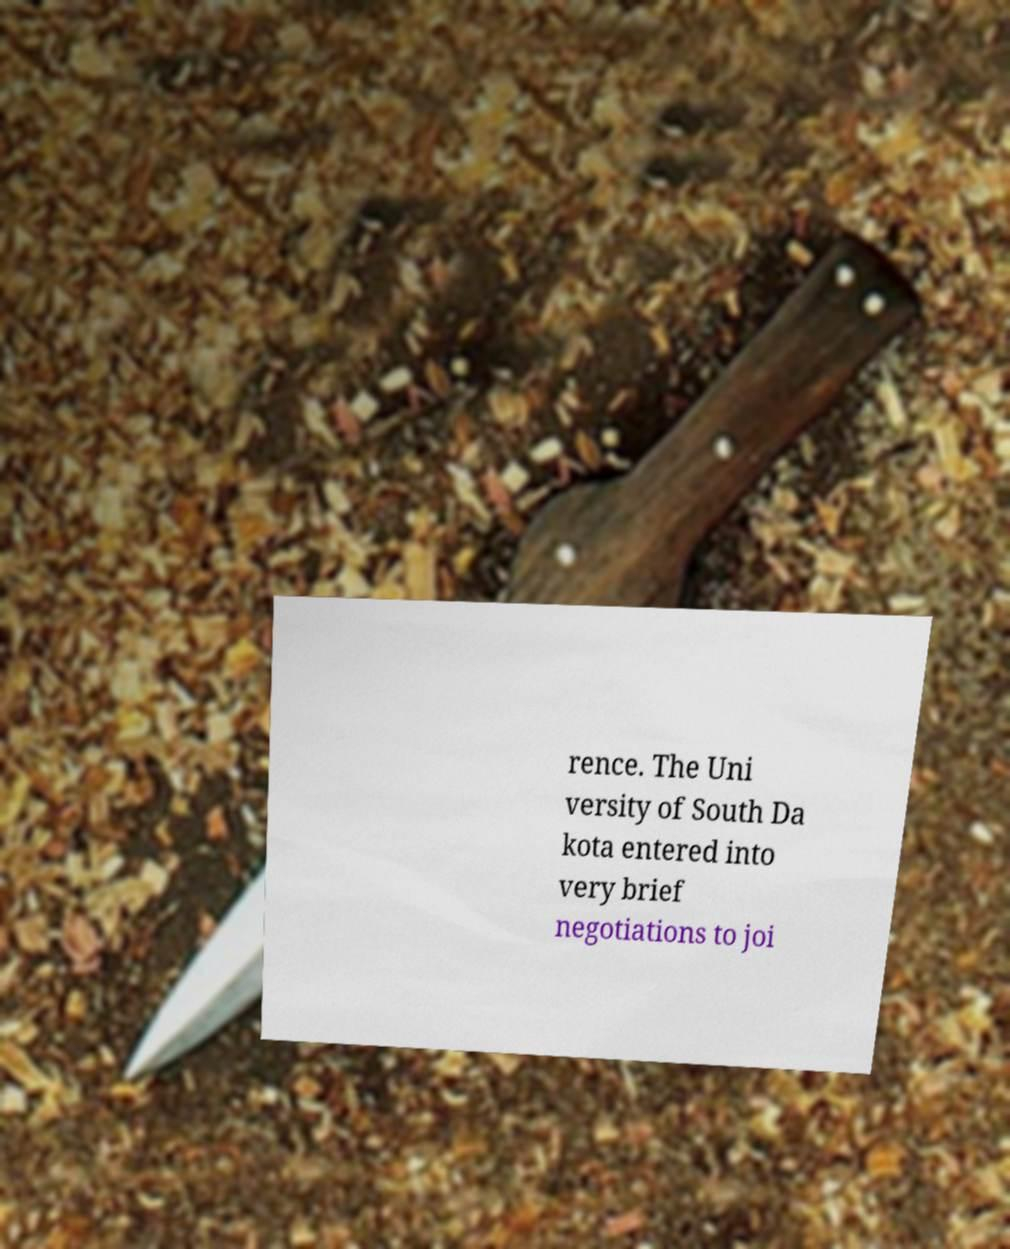Can you accurately transcribe the text from the provided image for me? rence. The Uni versity of South Da kota entered into very brief negotiations to joi 